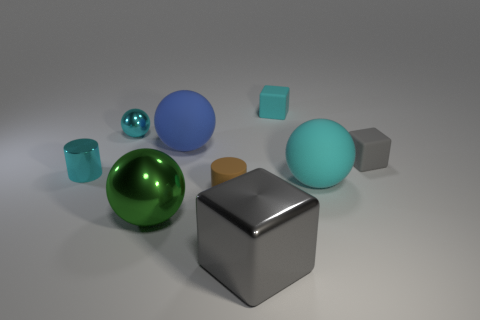Subtract all green spheres. How many spheres are left? 3 Subtract 2 spheres. How many spheres are left? 2 Subtract all yellow balls. Subtract all yellow cubes. How many balls are left? 4 Subtract all cylinders. How many objects are left? 7 Add 7 cyan matte objects. How many cyan matte objects are left? 9 Add 6 blue rubber balls. How many blue rubber balls exist? 7 Subtract 1 blue spheres. How many objects are left? 8 Subtract all gray shiny blocks. Subtract all big yellow blocks. How many objects are left? 8 